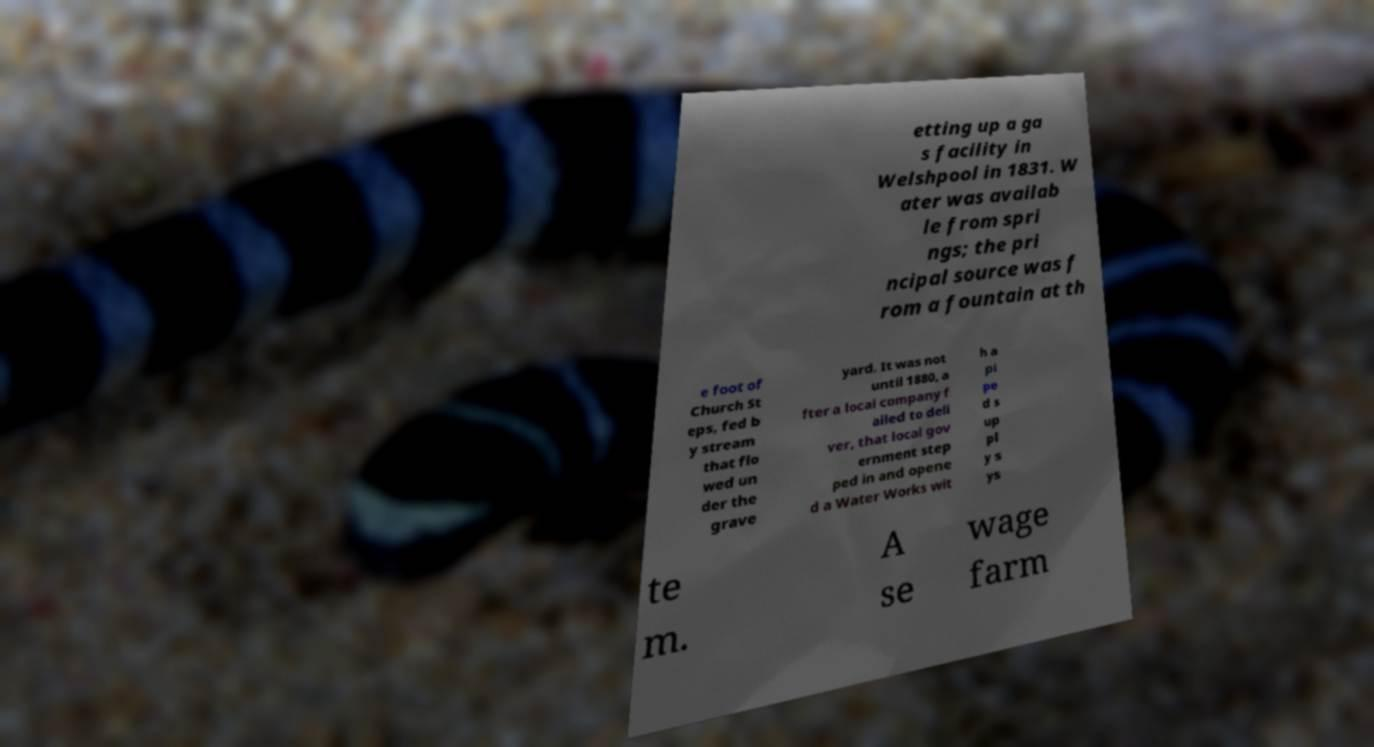Could you assist in decoding the text presented in this image and type it out clearly? etting up a ga s facility in Welshpool in 1831. W ater was availab le from spri ngs; the pri ncipal source was f rom a fountain at th e foot of Church St eps, fed b y stream that flo wed un der the grave yard. It was not until 1880, a fter a local company f ailed to deli ver, that local gov ernment step ped in and opene d a Water Works wit h a pi pe d s up pl y s ys te m. A se wage farm 